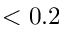<formula> <loc_0><loc_0><loc_500><loc_500>< 0 . 2</formula> 